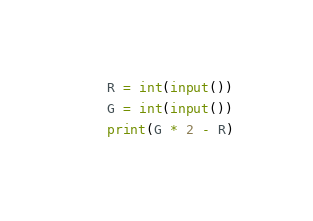Convert code to text. <code><loc_0><loc_0><loc_500><loc_500><_Python_>R = int(input())
G = int(input())
print(G * 2 - R)
</code> 